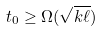Convert formula to latex. <formula><loc_0><loc_0><loc_500><loc_500>t _ { 0 } \geq \Omega ( \sqrt { k \ell } )</formula> 